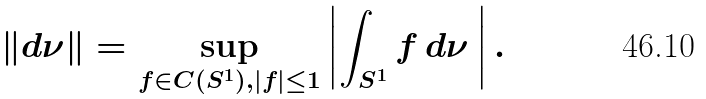Convert formula to latex. <formula><loc_0><loc_0><loc_500><loc_500>\| d \nu \| = \sup _ { f \in C ( S ^ { 1 } ) , | f | \leq 1 } \left | \int _ { S ^ { 1 } } f \, d \nu \, \right | .</formula> 